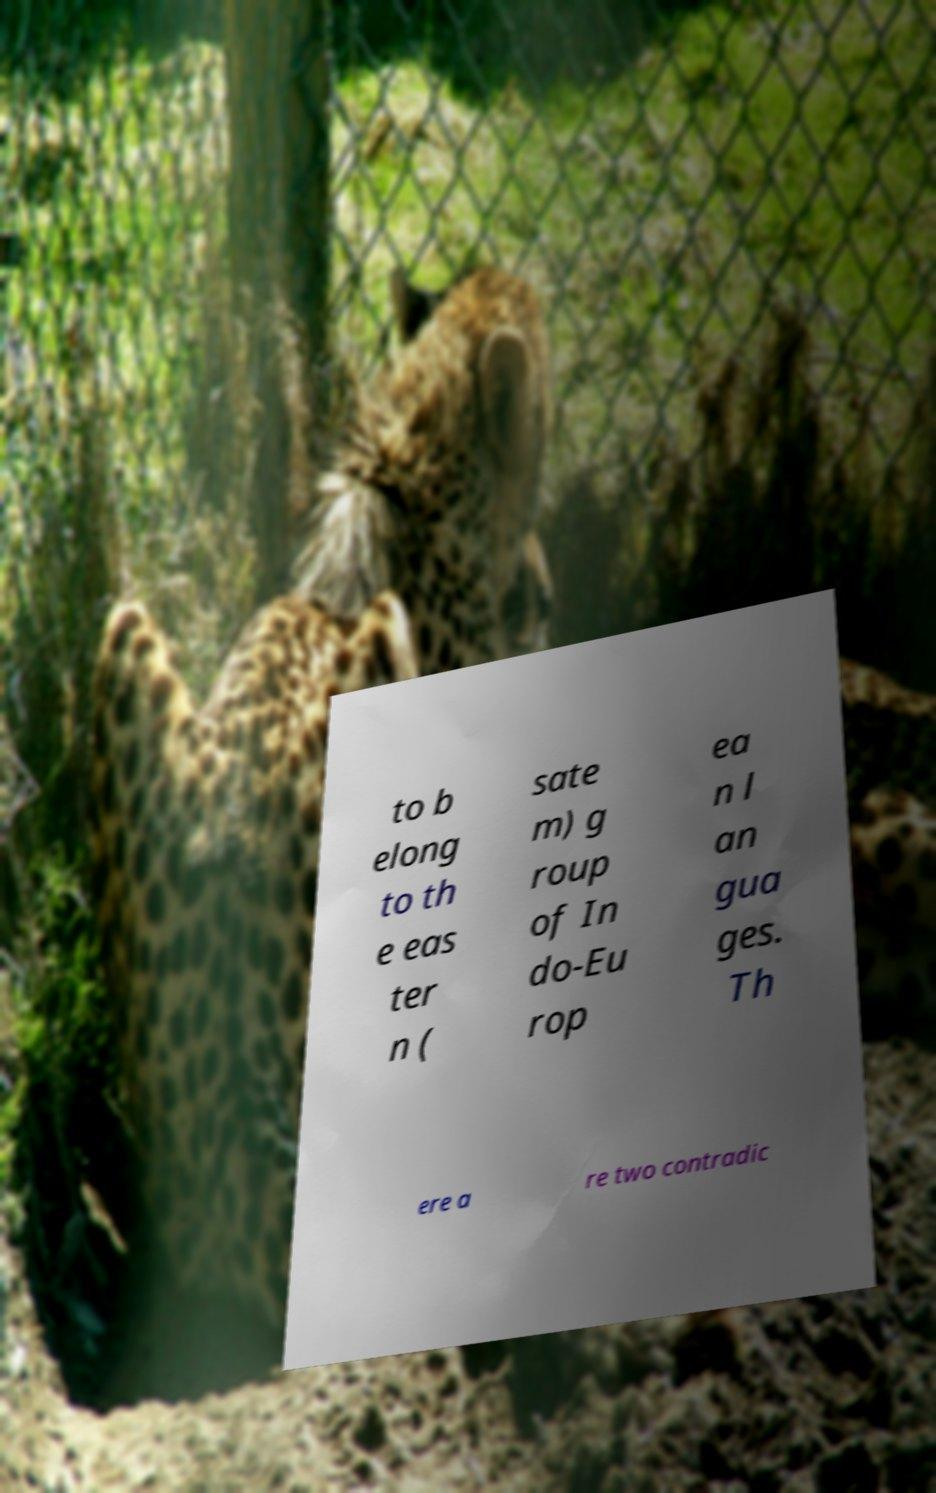Please identify and transcribe the text found in this image. to b elong to th e eas ter n ( sate m) g roup of In do-Eu rop ea n l an gua ges. Th ere a re two contradic 